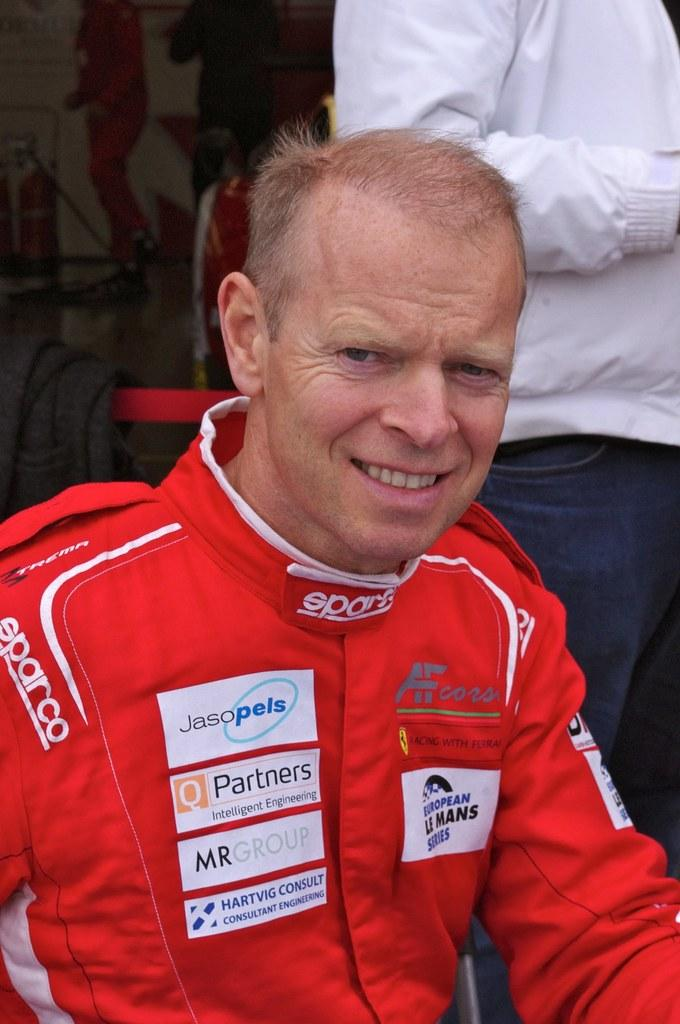<image>
Summarize the visual content of the image. Squinting man with short red hair wearing a red Sparco jacket. 